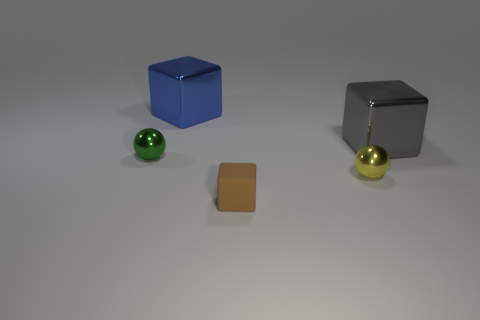What kind of lighting is present in the scene? The lighting in the scene is soft and diffuse, coming from above and casting gentle shadows directly underneath the objects. This suggests an indoor setting with either studio lighting or soft natural light filtered through a window.  Could you describe the atmosphere or mood that this image conveys? The image has a clean, minimalistic atmosphere, with a cool, neutral tone. The simplicity of the composition and the soft lighting convey a sense of order and calmness, making it visually pleasing and tranquil. 